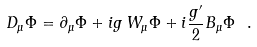Convert formula to latex. <formula><loc_0><loc_0><loc_500><loc_500>D _ { \mu } \Phi = \partial _ { \mu } \Phi + i g \, W _ { \mu } \Phi + i \frac { g ^ { \prime } } { 2 } B _ { \mu } \Phi \ .</formula> 